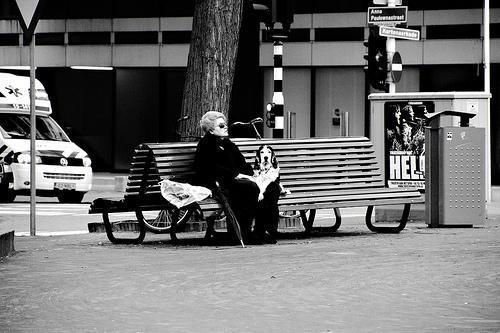How many dogs in photo?
Give a very brief answer. 1. How many benches?
Give a very brief answer. 2. 